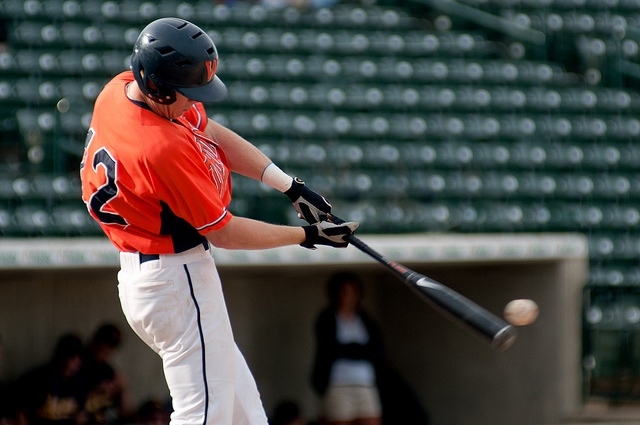<image>Who is sponsoring this player? I am not sure who is sponsoring this player. It might be 'nike' or 'corporation'. Who is sponsoring this player? I am not sure who is sponsoring this player. It can be Nike or another corporation. 